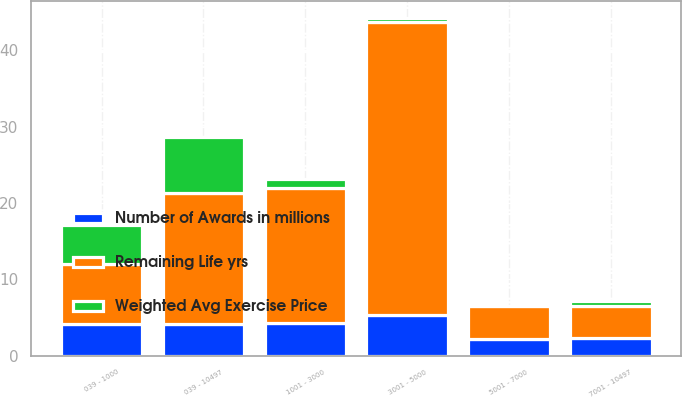<chart> <loc_0><loc_0><loc_500><loc_500><stacked_bar_chart><ecel><fcel>039 - 1000<fcel>1001 - 3000<fcel>3001 - 5000<fcel>5001 - 7000<fcel>7001 - 10497<fcel>039 - 10497<nl><fcel>Weighted Avg Exercise Price<fcel>5.1<fcel>1.1<fcel>0.5<fcel>0.1<fcel>0.6<fcel>7.4<nl><fcel>Number of Awards in millions<fcel>4.2<fcel>4.3<fcel>5.3<fcel>2.2<fcel>2.3<fcel>4.1<nl><fcel>Remaining Life yrs<fcel>7.78<fcel>17.7<fcel>38.39<fcel>4.25<fcel>4.25<fcel>17.18<nl></chart> 